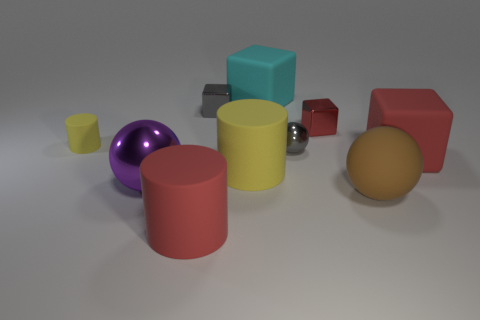What is the size of the object that is the same color as the tiny matte cylinder?
Make the answer very short. Large. There is another big object that is the same shape as the big purple thing; what color is it?
Make the answer very short. Brown. What number of blocks are large gray shiny objects or red matte objects?
Give a very brief answer. 1. The big cyan thing has what shape?
Keep it short and to the point. Cube. There is a large brown rubber thing; are there any brown matte objects behind it?
Offer a terse response. No. Does the cyan object have the same material as the tiny cube left of the red metallic cube?
Keep it short and to the point. No. There is a big purple metal thing that is to the left of the gray sphere; is its shape the same as the small red object?
Provide a short and direct response. No. What number of large cyan things have the same material as the purple thing?
Offer a very short reply. 0. How many things are yellow rubber objects that are right of the small yellow rubber thing or large cyan rubber blocks?
Provide a short and direct response. 2. What is the size of the brown matte sphere?
Offer a terse response. Large. 